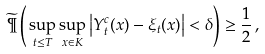<formula> <loc_0><loc_0><loc_500><loc_500>\widetilde { \P } \left ( \, \sup _ { t \leq T } \sup _ { x \in K } \left | Y ^ { c } _ { t } ( x ) - \xi _ { t } ( x ) \right | < \delta \right ) \geq \frac { 1 } { 2 } \, ,</formula> 